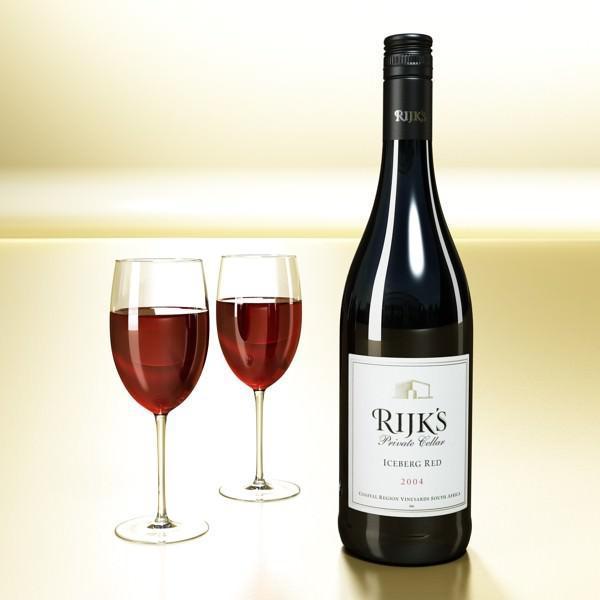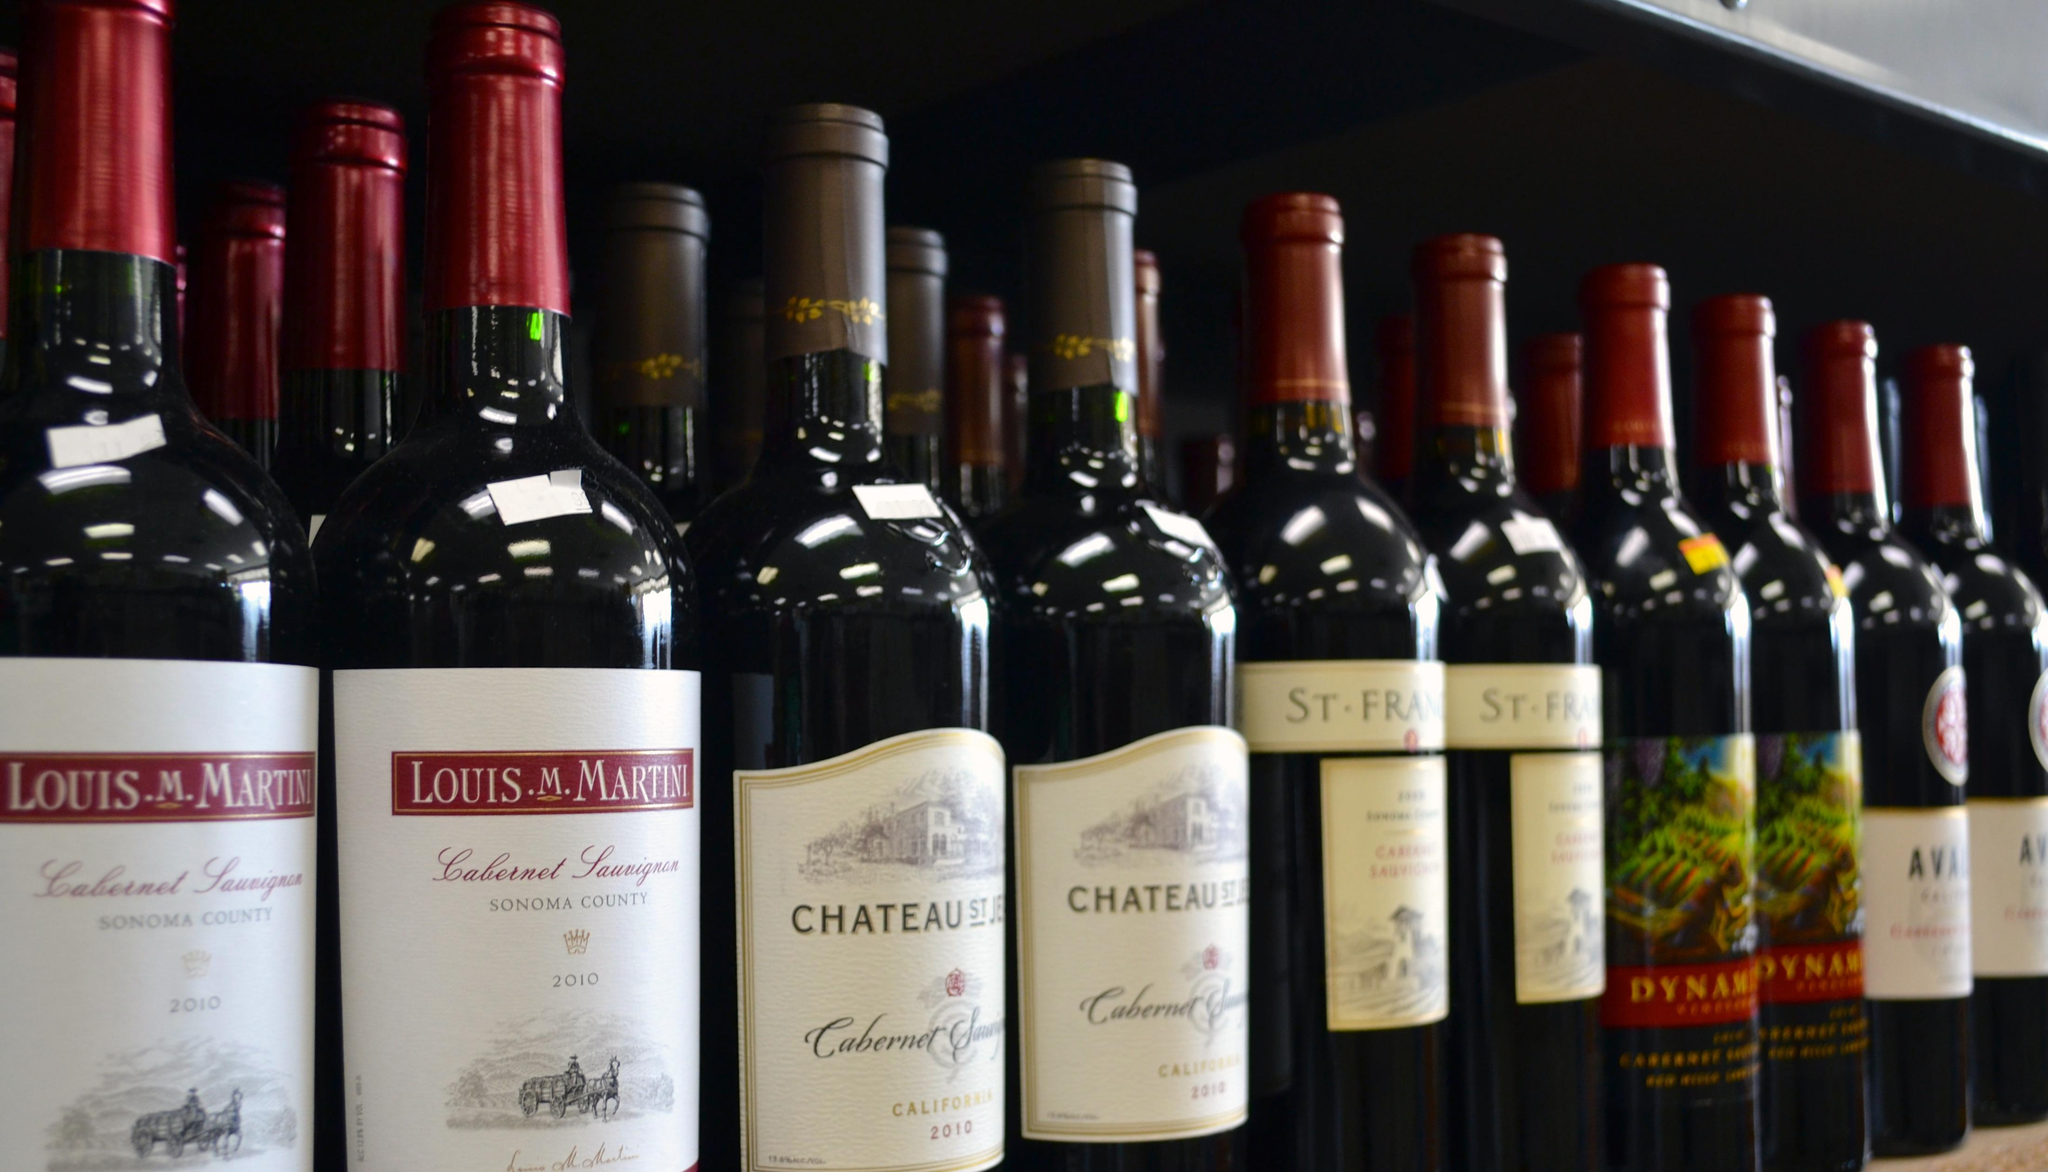The first image is the image on the left, the second image is the image on the right. Evaluate the accuracy of this statement regarding the images: "The left image includes two wine glasses.". Is it true? Answer yes or no. Yes. The first image is the image on the left, the second image is the image on the right. Given the left and right images, does the statement "A single bottle of wine stands in the image on the left." hold true? Answer yes or no. Yes. 